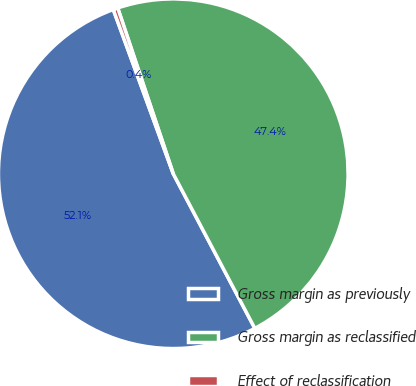Convert chart to OTSL. <chart><loc_0><loc_0><loc_500><loc_500><pie_chart><fcel>Gross margin as previously<fcel>Gross margin as reclassified<fcel>Effect of reclassification<nl><fcel>52.15%<fcel>47.42%<fcel>0.43%<nl></chart> 